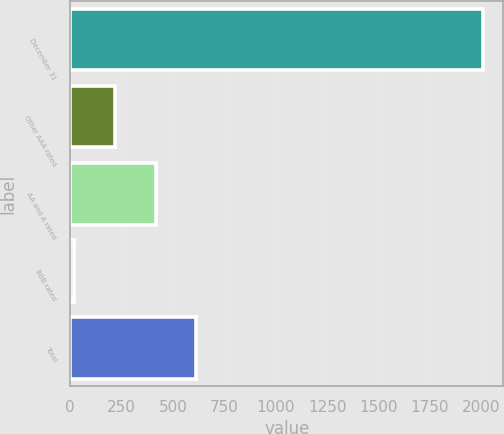Convert chart to OTSL. <chart><loc_0><loc_0><loc_500><loc_500><bar_chart><fcel>December 31<fcel>Other AAA rated<fcel>AA and A rated<fcel>BBB rated<fcel>Total<nl><fcel>2006<fcel>216.17<fcel>415.04<fcel>17.3<fcel>613.91<nl></chart> 